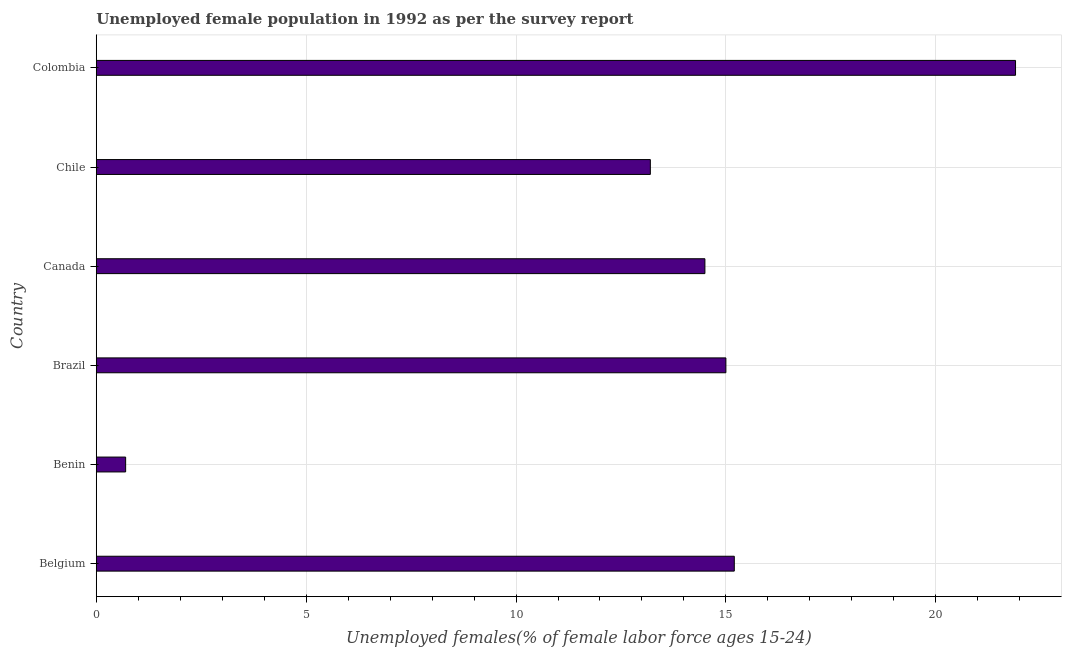Does the graph contain any zero values?
Give a very brief answer. No. Does the graph contain grids?
Your answer should be very brief. Yes. What is the title of the graph?
Offer a terse response. Unemployed female population in 1992 as per the survey report. What is the label or title of the X-axis?
Make the answer very short. Unemployed females(% of female labor force ages 15-24). What is the label or title of the Y-axis?
Ensure brevity in your answer.  Country. What is the unemployed female youth in Canada?
Give a very brief answer. 14.5. Across all countries, what is the maximum unemployed female youth?
Make the answer very short. 21.9. Across all countries, what is the minimum unemployed female youth?
Provide a succinct answer. 0.7. In which country was the unemployed female youth minimum?
Your answer should be compact. Benin. What is the sum of the unemployed female youth?
Make the answer very short. 80.5. What is the difference between the unemployed female youth in Belgium and Canada?
Ensure brevity in your answer.  0.7. What is the average unemployed female youth per country?
Your response must be concise. 13.42. What is the median unemployed female youth?
Provide a short and direct response. 14.75. What is the ratio of the unemployed female youth in Brazil to that in Canada?
Ensure brevity in your answer.  1.03. Is the unemployed female youth in Brazil less than that in Colombia?
Provide a succinct answer. Yes. Is the difference between the unemployed female youth in Belgium and Chile greater than the difference between any two countries?
Provide a short and direct response. No. What is the difference between the highest and the second highest unemployed female youth?
Offer a very short reply. 6.7. What is the difference between the highest and the lowest unemployed female youth?
Your answer should be compact. 21.2. In how many countries, is the unemployed female youth greater than the average unemployed female youth taken over all countries?
Your answer should be compact. 4. Are all the bars in the graph horizontal?
Offer a very short reply. Yes. How many countries are there in the graph?
Offer a very short reply. 6. What is the Unemployed females(% of female labor force ages 15-24) in Belgium?
Give a very brief answer. 15.2. What is the Unemployed females(% of female labor force ages 15-24) in Benin?
Provide a succinct answer. 0.7. What is the Unemployed females(% of female labor force ages 15-24) in Brazil?
Provide a succinct answer. 15. What is the Unemployed females(% of female labor force ages 15-24) in Canada?
Ensure brevity in your answer.  14.5. What is the Unemployed females(% of female labor force ages 15-24) in Chile?
Give a very brief answer. 13.2. What is the Unemployed females(% of female labor force ages 15-24) of Colombia?
Give a very brief answer. 21.9. What is the difference between the Unemployed females(% of female labor force ages 15-24) in Belgium and Benin?
Provide a short and direct response. 14.5. What is the difference between the Unemployed females(% of female labor force ages 15-24) in Belgium and Colombia?
Ensure brevity in your answer.  -6.7. What is the difference between the Unemployed females(% of female labor force ages 15-24) in Benin and Brazil?
Make the answer very short. -14.3. What is the difference between the Unemployed females(% of female labor force ages 15-24) in Benin and Canada?
Offer a very short reply. -13.8. What is the difference between the Unemployed females(% of female labor force ages 15-24) in Benin and Colombia?
Keep it short and to the point. -21.2. What is the difference between the Unemployed females(% of female labor force ages 15-24) in Brazil and Canada?
Keep it short and to the point. 0.5. What is the difference between the Unemployed females(% of female labor force ages 15-24) in Brazil and Chile?
Make the answer very short. 1.8. What is the difference between the Unemployed females(% of female labor force ages 15-24) in Brazil and Colombia?
Your answer should be compact. -6.9. What is the difference between the Unemployed females(% of female labor force ages 15-24) in Canada and Chile?
Give a very brief answer. 1.3. What is the difference between the Unemployed females(% of female labor force ages 15-24) in Canada and Colombia?
Your answer should be very brief. -7.4. What is the ratio of the Unemployed females(% of female labor force ages 15-24) in Belgium to that in Benin?
Your response must be concise. 21.71. What is the ratio of the Unemployed females(% of female labor force ages 15-24) in Belgium to that in Canada?
Your response must be concise. 1.05. What is the ratio of the Unemployed females(% of female labor force ages 15-24) in Belgium to that in Chile?
Your answer should be compact. 1.15. What is the ratio of the Unemployed females(% of female labor force ages 15-24) in Belgium to that in Colombia?
Your answer should be very brief. 0.69. What is the ratio of the Unemployed females(% of female labor force ages 15-24) in Benin to that in Brazil?
Provide a short and direct response. 0.05. What is the ratio of the Unemployed females(% of female labor force ages 15-24) in Benin to that in Canada?
Your response must be concise. 0.05. What is the ratio of the Unemployed females(% of female labor force ages 15-24) in Benin to that in Chile?
Keep it short and to the point. 0.05. What is the ratio of the Unemployed females(% of female labor force ages 15-24) in Benin to that in Colombia?
Provide a succinct answer. 0.03. What is the ratio of the Unemployed females(% of female labor force ages 15-24) in Brazil to that in Canada?
Ensure brevity in your answer.  1.03. What is the ratio of the Unemployed females(% of female labor force ages 15-24) in Brazil to that in Chile?
Provide a short and direct response. 1.14. What is the ratio of the Unemployed females(% of female labor force ages 15-24) in Brazil to that in Colombia?
Give a very brief answer. 0.69. What is the ratio of the Unemployed females(% of female labor force ages 15-24) in Canada to that in Chile?
Ensure brevity in your answer.  1.1. What is the ratio of the Unemployed females(% of female labor force ages 15-24) in Canada to that in Colombia?
Make the answer very short. 0.66. What is the ratio of the Unemployed females(% of female labor force ages 15-24) in Chile to that in Colombia?
Provide a short and direct response. 0.6. 